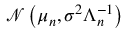Convert formula to latex. <formula><loc_0><loc_0><loc_500><loc_500>{ \mathcal { N } } \left ( { \mu } _ { n } , \sigma ^ { 2 } { \Lambda } _ { n } ^ { - 1 } \right )</formula> 